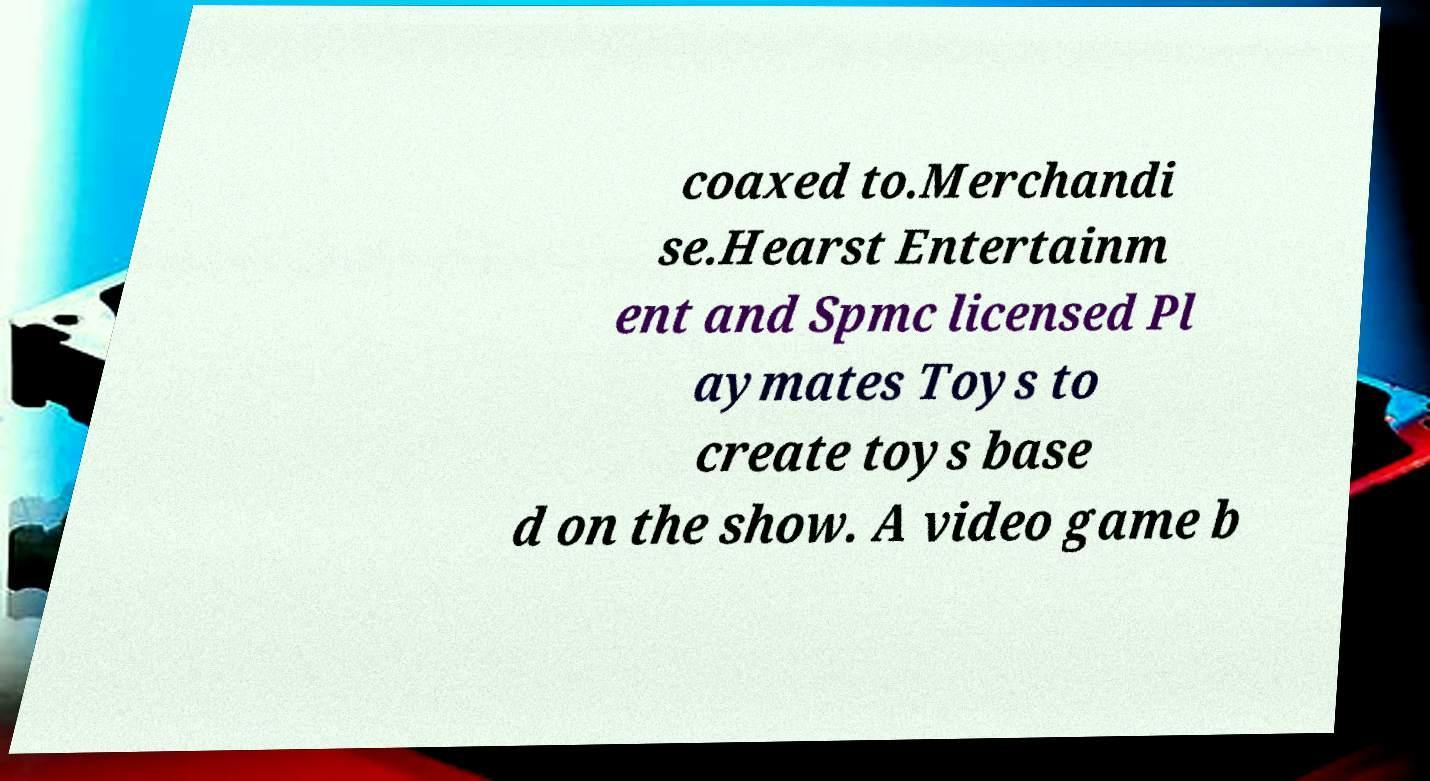Please identify and transcribe the text found in this image. coaxed to.Merchandi se.Hearst Entertainm ent and Spmc licensed Pl aymates Toys to create toys base d on the show. A video game b 